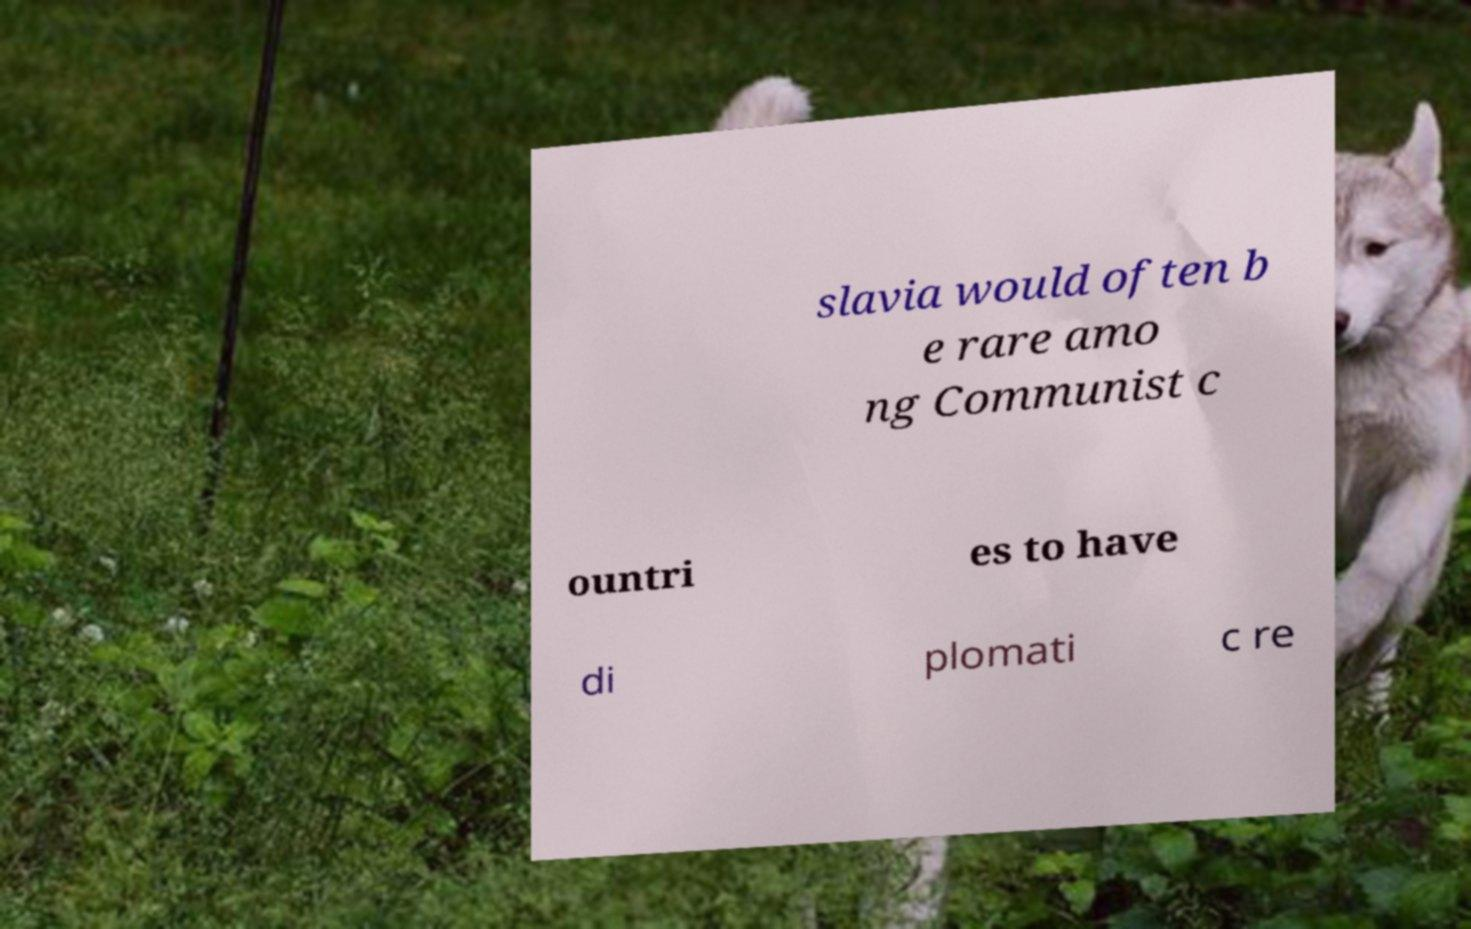Could you extract and type out the text from this image? slavia would often b e rare amo ng Communist c ountri es to have di plomati c re 